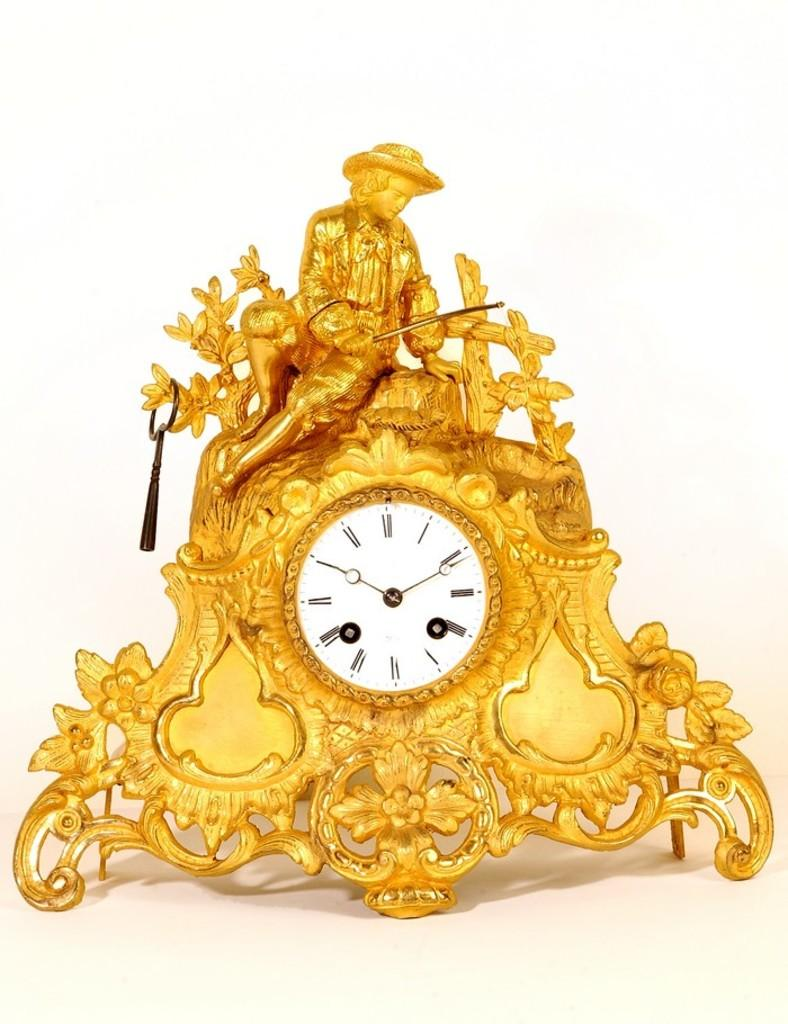<image>
Create a compact narrative representing the image presented. A intricate gold clock with roman numerals on the face pointing at two fifty in the afternoon. 